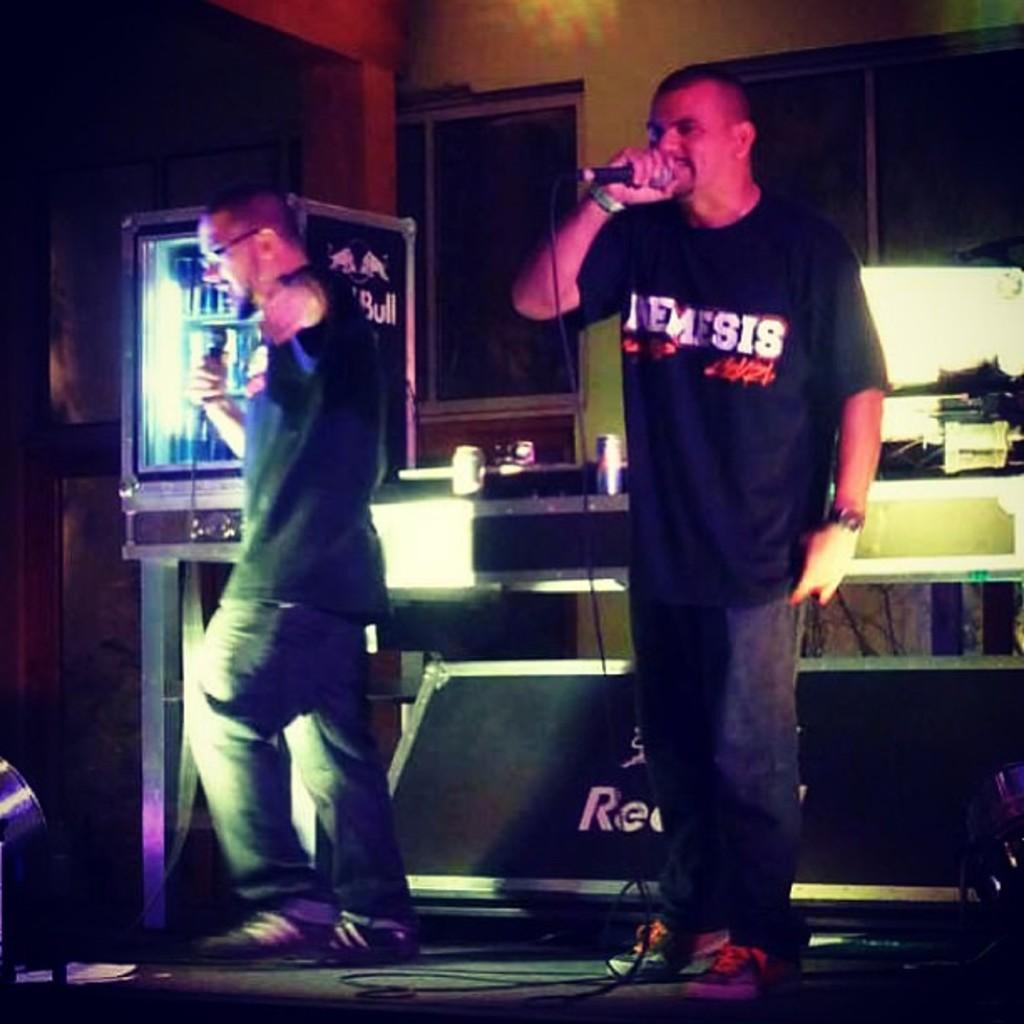What are the people on the stage doing? The people on the stage are holding microphones in their hands. What might the people on the stage be doing with the microphones? They might be using the microphones to speak or sing in front of an audience. Can you describe the box in the image? Yes, the box contains juice cans. What is the purpose of the box in the image? The box might be used for storage or transportation of the juice cans. Can you see a bee buzzing around the microphones in the image? There is no bee present in the image. What type of spot is visible on the stage in the image? There is no spot mentioned or visible in the image. 